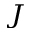<formula> <loc_0><loc_0><loc_500><loc_500>_ { J }</formula> 